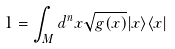<formula> <loc_0><loc_0><loc_500><loc_500>1 = \int _ { M } d ^ { n } x \sqrt { g ( x ) } | x \rangle \langle x |</formula> 